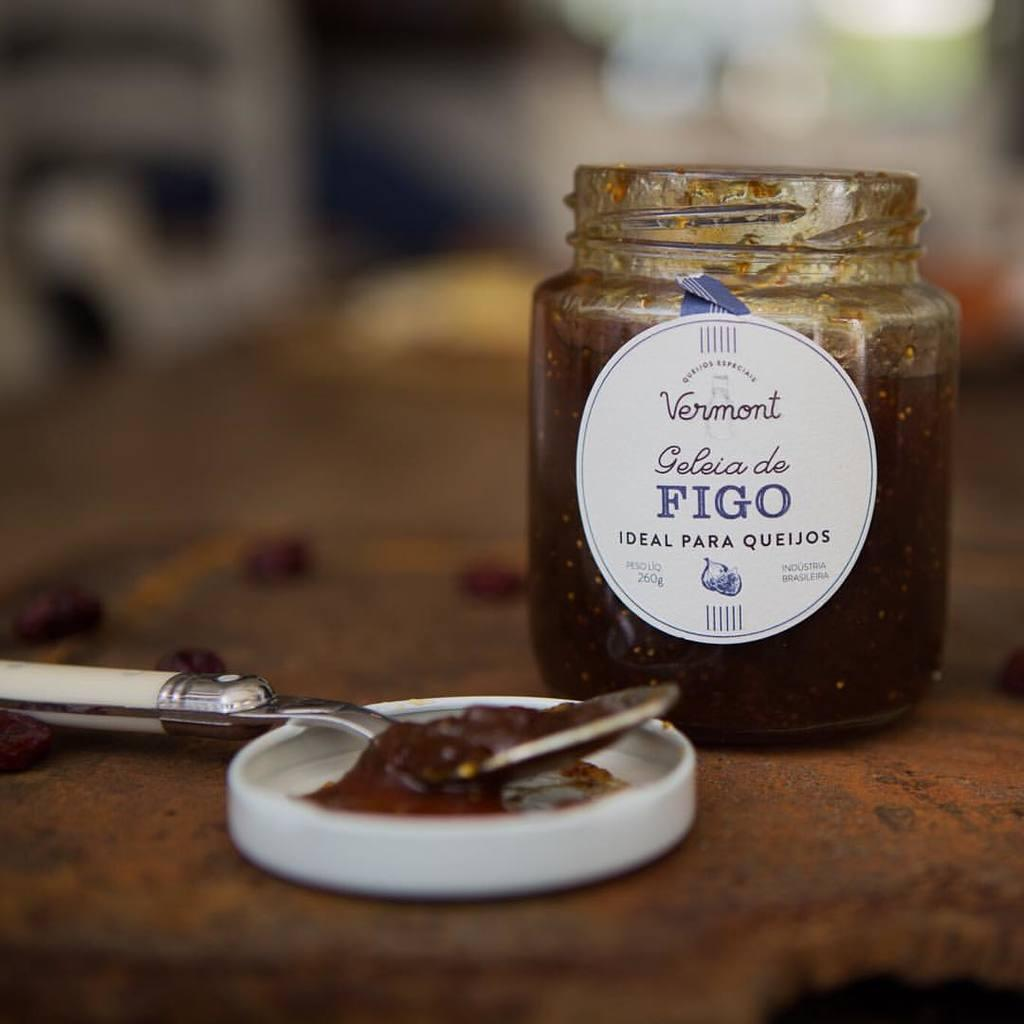What object can be seen in the image that is typically used for storage? There is a jar in the image that is typically used for storage. What utensil is visible in the image? There is a spoon in the image. Where are the jar and spoon located in the image? The jar and spoon are placed on a table. What is the name of the person holding the spoon in the image? There is no person holding the spoon in the image; it is placed on a table. What type of clouds can be seen in the image? There are no clouds visible in the image, as it only features a jar and spoon on a table. 